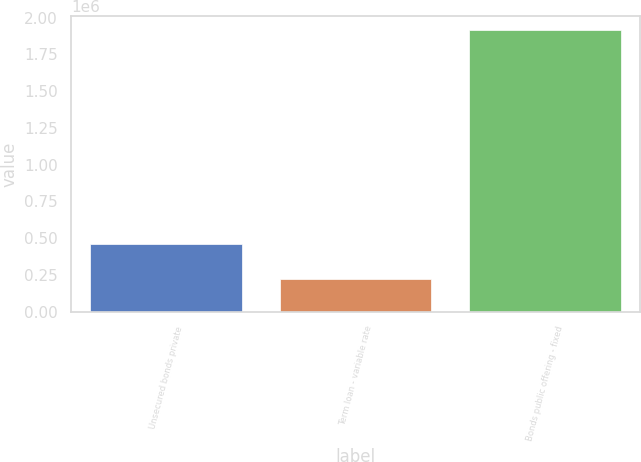<chart> <loc_0><loc_0><loc_500><loc_500><bar_chart><fcel>Unsecured bonds private<fcel>Term loan - variable rate<fcel>Bonds public offering - fixed<nl><fcel>463443<fcel>224130<fcel>1.91598e+06<nl></chart> 